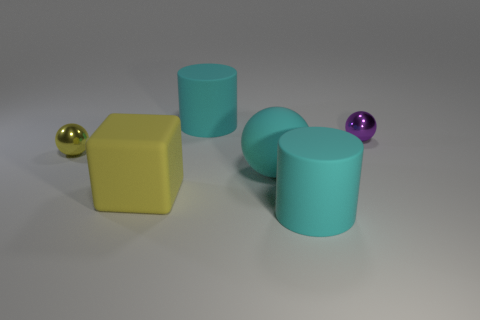There is a tiny object that is the same color as the big cube; what is its shape?
Provide a short and direct response. Sphere. How many objects are either metallic things that are left of the yellow cube or things behind the large cyan ball?
Your answer should be compact. 3. What size is the sphere that is made of the same material as the yellow cube?
Offer a terse response. Large. Does the purple metal object behind the matte block have the same shape as the large yellow object?
Your response must be concise. No. What is the size of the shiny object that is the same color as the large matte cube?
Offer a terse response. Small. What number of yellow things are either large cylinders or large cubes?
Make the answer very short. 1. How many other things are the same shape as the purple object?
Provide a succinct answer. 2. There is a large rubber thing that is behind the big yellow rubber block and in front of the tiny purple object; what shape is it?
Offer a very short reply. Sphere. There is a big matte block; are there any tiny yellow balls left of it?
Your answer should be very brief. Yes. What size is the yellow shiny object that is the same shape as the purple metallic thing?
Make the answer very short. Small. 